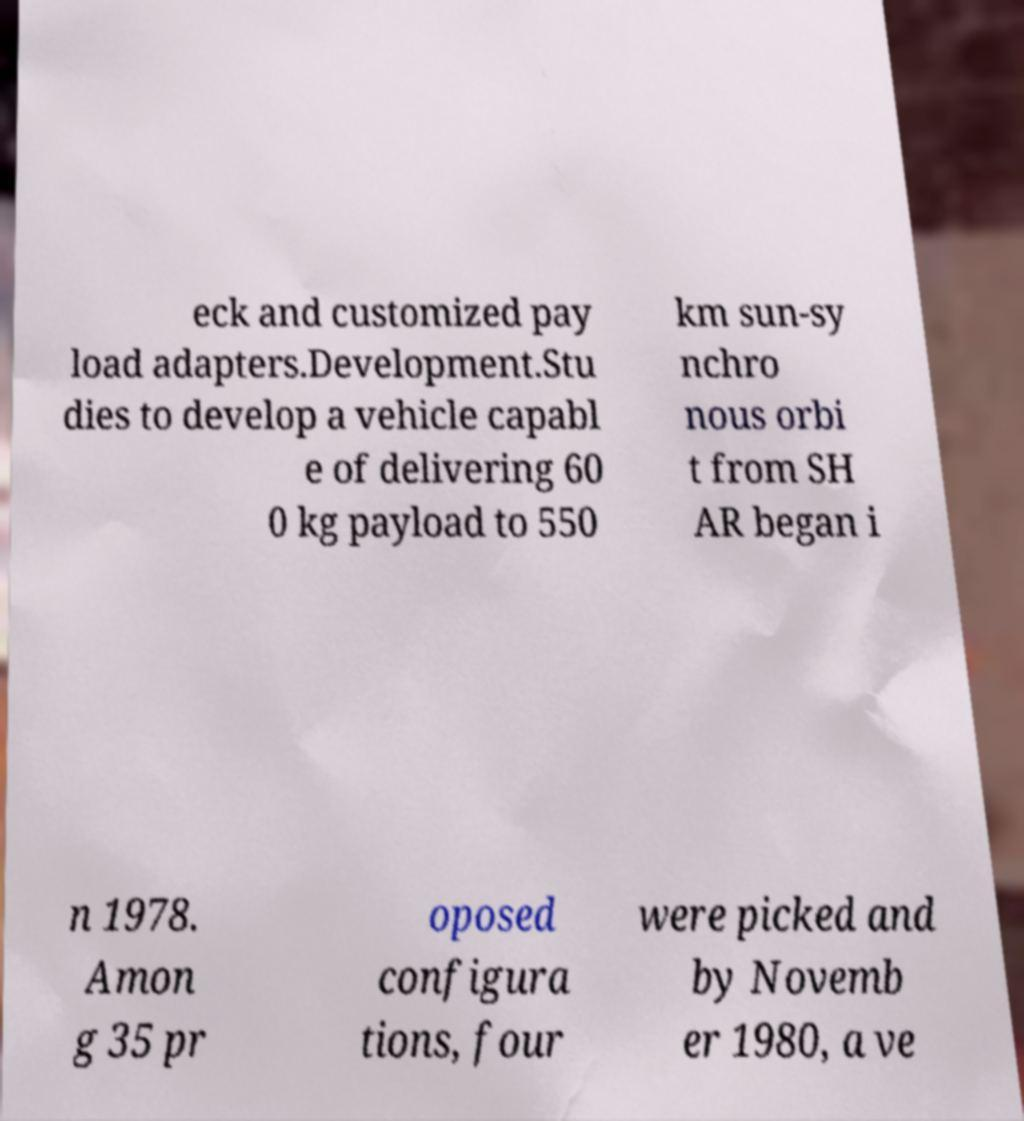For documentation purposes, I need the text within this image transcribed. Could you provide that? eck and customized pay load adapters.Development.Stu dies to develop a vehicle capabl e of delivering 60 0 kg payload to 550 km sun-sy nchro nous orbi t from SH AR began i n 1978. Amon g 35 pr oposed configura tions, four were picked and by Novemb er 1980, a ve 